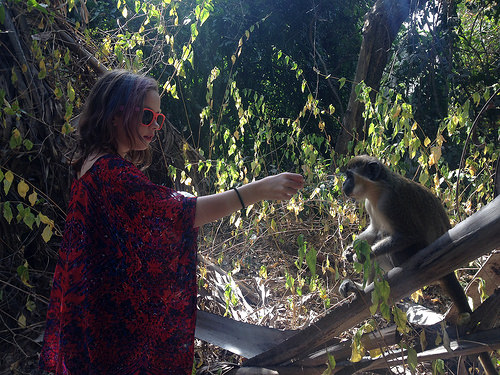<image>
Can you confirm if the girl is next to the monkey? Yes. The girl is positioned adjacent to the monkey, located nearby in the same general area. Is the monkey in front of the woman? Yes. The monkey is positioned in front of the woman, appearing closer to the camera viewpoint. 